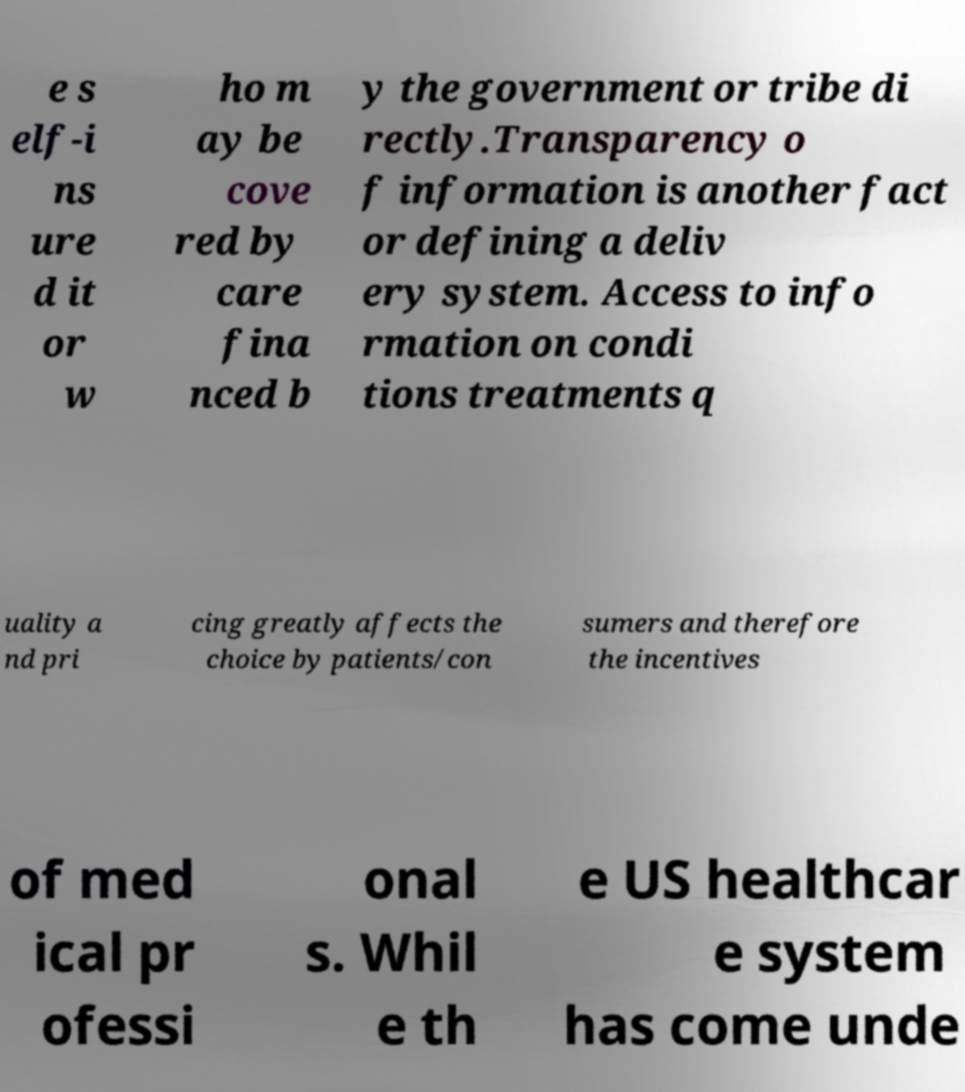There's text embedded in this image that I need extracted. Can you transcribe it verbatim? e s elf-i ns ure d it or w ho m ay be cove red by care fina nced b y the government or tribe di rectly.Transparency o f information is another fact or defining a deliv ery system. Access to info rmation on condi tions treatments q uality a nd pri cing greatly affects the choice by patients/con sumers and therefore the incentives of med ical pr ofessi onal s. Whil e th e US healthcar e system has come unde 